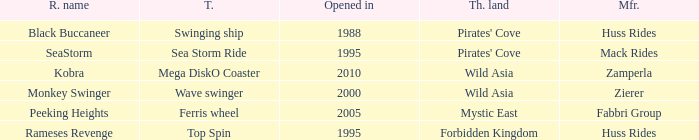What type ride is Wild Asia that opened in 2000? Wave swinger. 